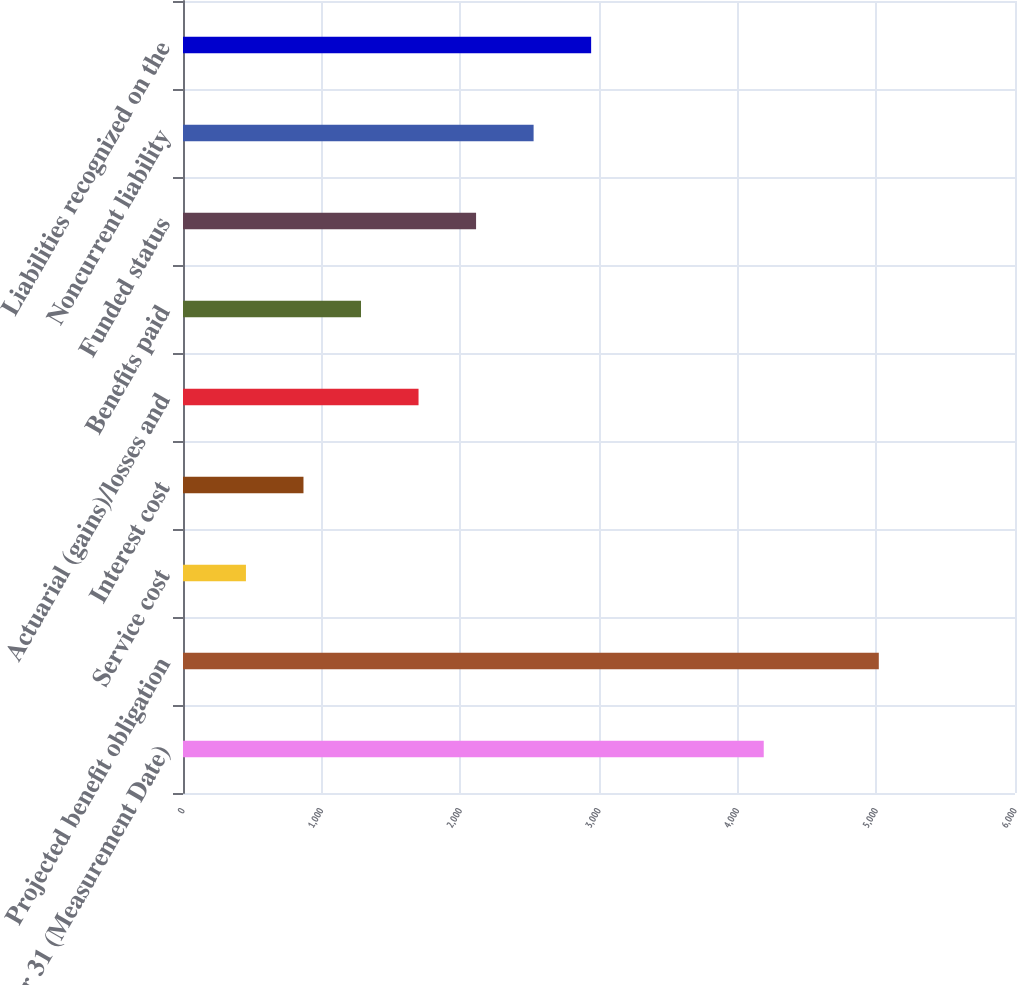Convert chart. <chart><loc_0><loc_0><loc_500><loc_500><bar_chart><fcel>December 31 (Measurement Date)<fcel>Projected benefit obligation<fcel>Service cost<fcel>Interest cost<fcel>Actuarial (gains)/losses and<fcel>Benefits paid<fcel>Funded status<fcel>Noncurrent liability<fcel>Liabilities recognized on the<nl><fcel>4188<fcel>5017.8<fcel>453.9<fcel>868.8<fcel>1698.6<fcel>1283.7<fcel>2113.5<fcel>2528.4<fcel>2943.3<nl></chart> 